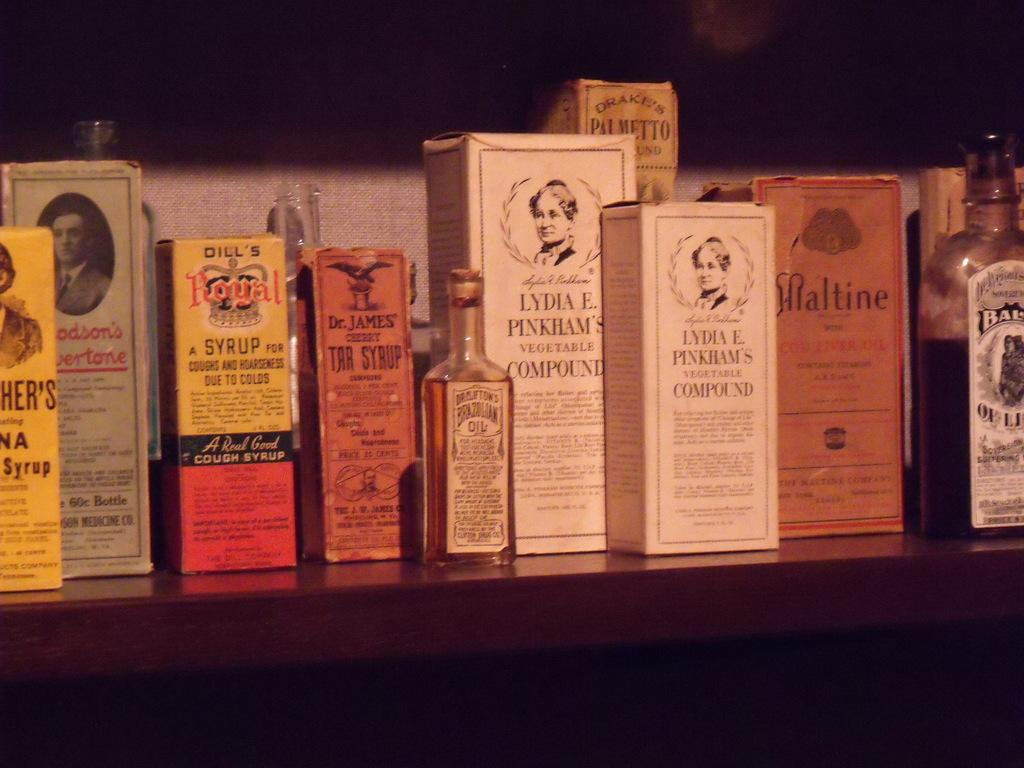What objects are present in the image that are grouped together? There is a group of bottles and a group of boxes in the image. What can be seen on the surfaces of the bottles and boxes? The bottles and boxes have pictures and text on them. What type of surface are the bottles and boxes placed on? The bottles and boxes are placed on a wooden surface. What can be seen in the background of the image? There is a wall visible in the background of the image. What type of chain can be seen connecting the bottles and boxes in the image? There is no chain connecting the bottles and boxes in the image. What type of oil is visible on the wooden surface in the image? There is no oil visible on the wooden surface in the image. 